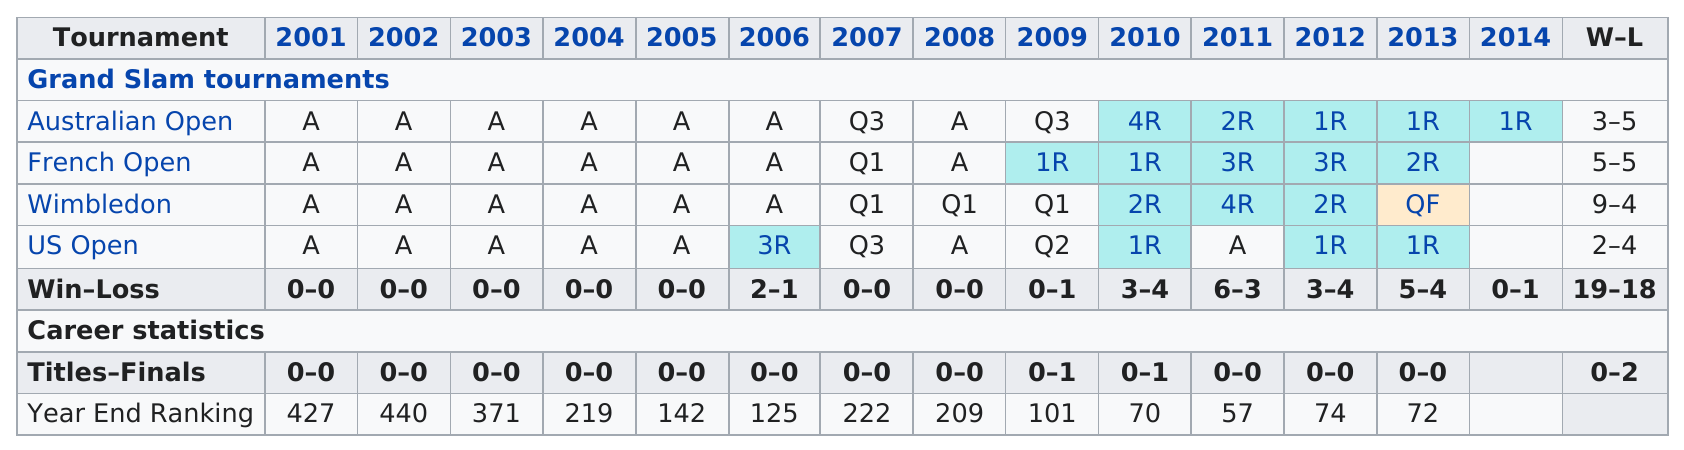Point out several critical features in this image. According to the player's ranking following the 2005 tournament, they were ranked at number 125. This player's average ranking between 2001 and 2006 was 287. The French Open has a record of 5-5 as its win-loss record. The ranking below 200 was achieved in the years 2005, 2006, 2009, 2010, 2011, 2012, 2013. In the period from 2001 to 2014, a total of 37 matches were played. 